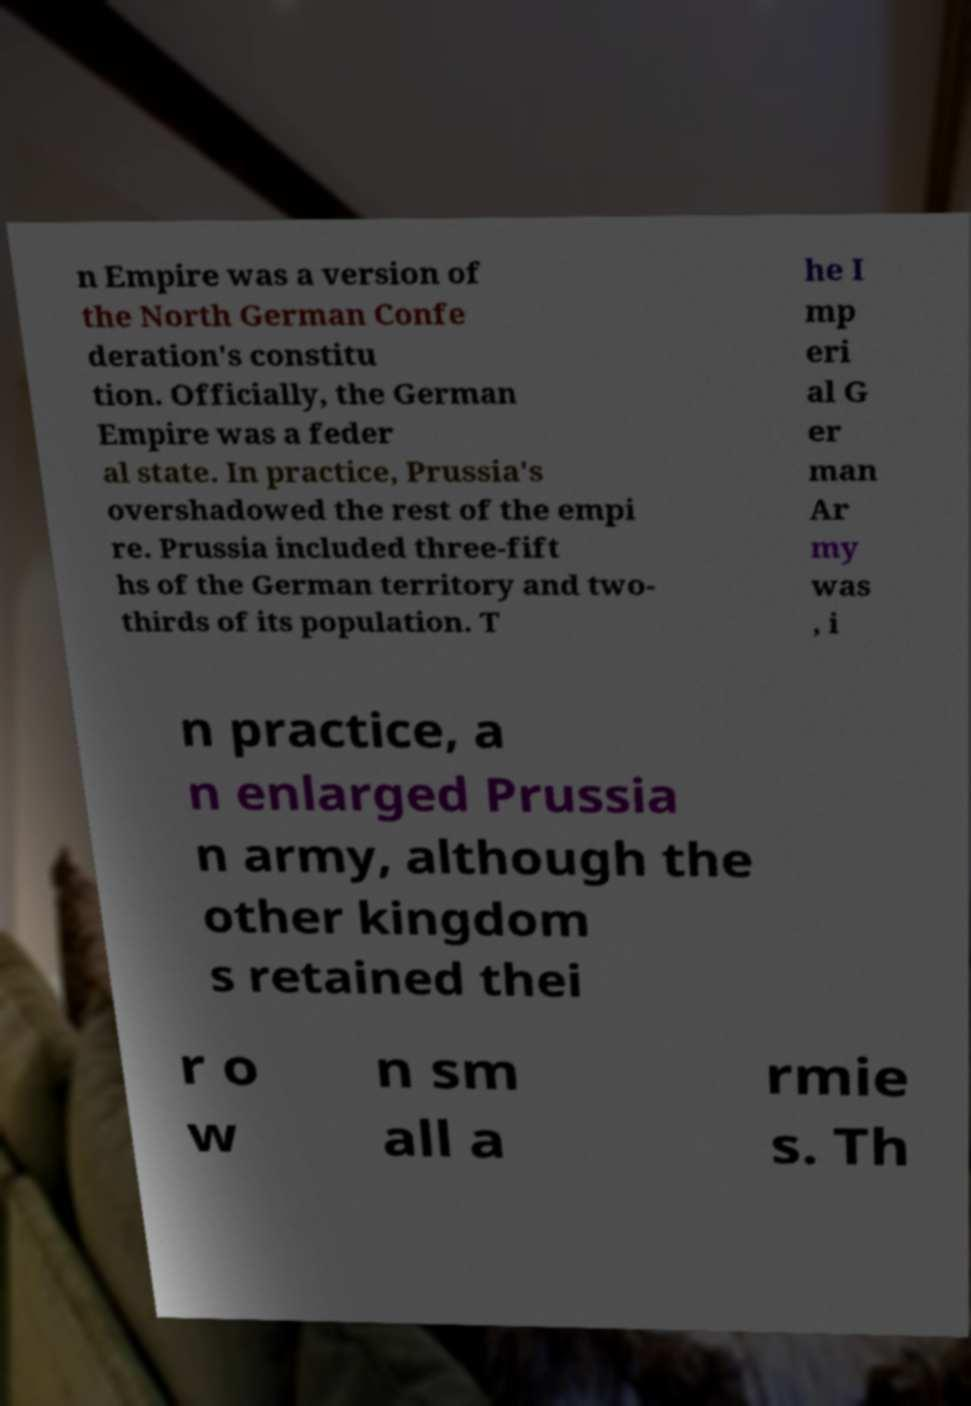What messages or text are displayed in this image? I need them in a readable, typed format. n Empire was a version of the North German Confe deration's constitu tion. Officially, the German Empire was a feder al state. In practice, Prussia's overshadowed the rest of the empi re. Prussia included three-fift hs of the German territory and two- thirds of its population. T he I mp eri al G er man Ar my was , i n practice, a n enlarged Prussia n army, although the other kingdom s retained thei r o w n sm all a rmie s. Th 